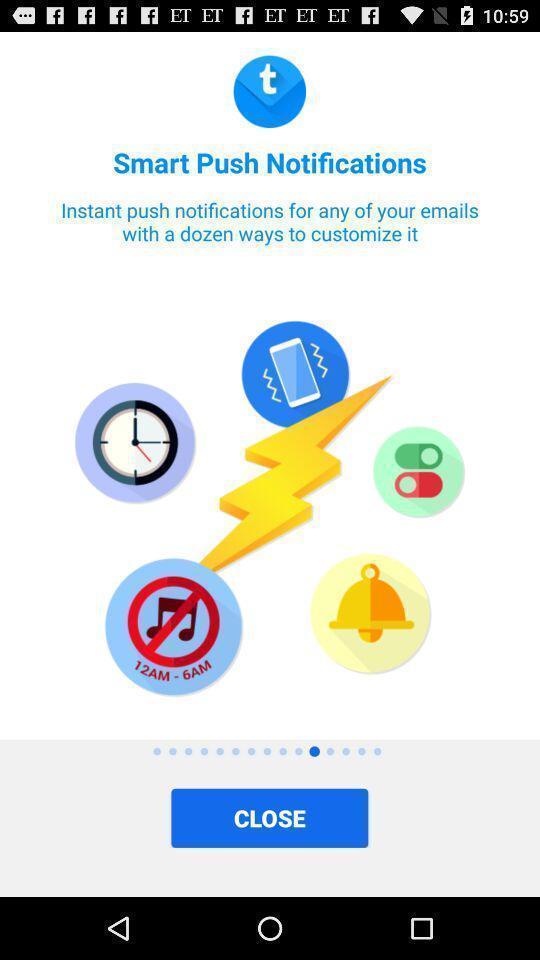Tell me what you see in this picture. Screen displaying introductory page. 